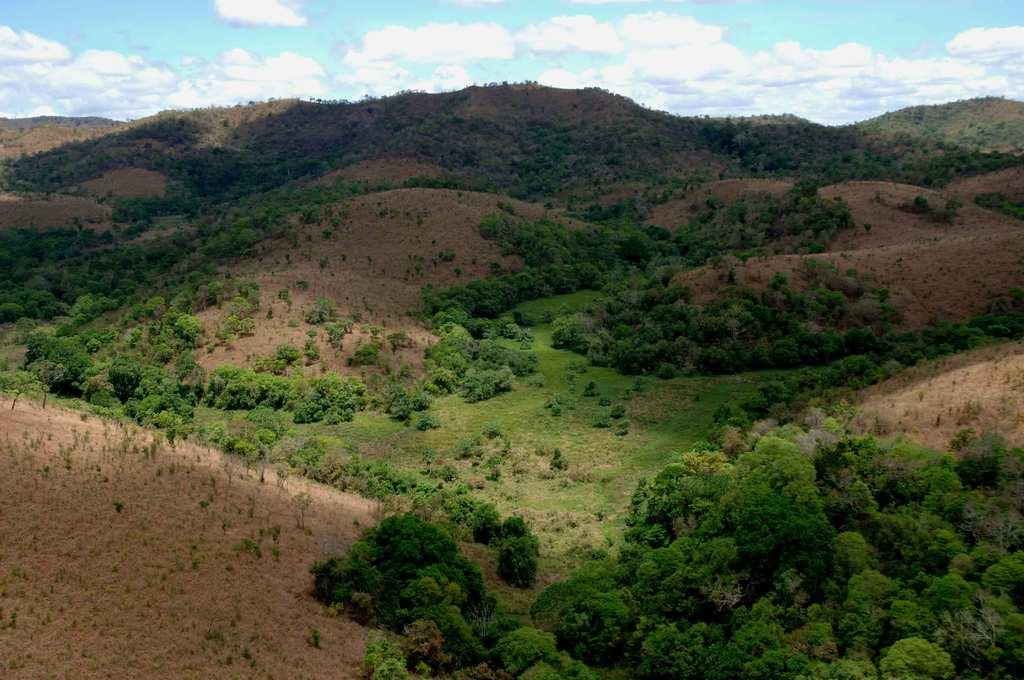What type of natural elements can be seen in the image? There are trees and hills visible in the image. What part of the natural environment is visible in the image? The sky is visible in the image. What type of texture can be seen on the dirt in the image? There is no dirt present in the image; it features trees, hills, and the sky. 